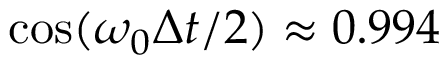Convert formula to latex. <formula><loc_0><loc_0><loc_500><loc_500>\cos ( \omega _ { 0 } \Delta t / 2 ) \approx 0 . 9 9 4</formula> 